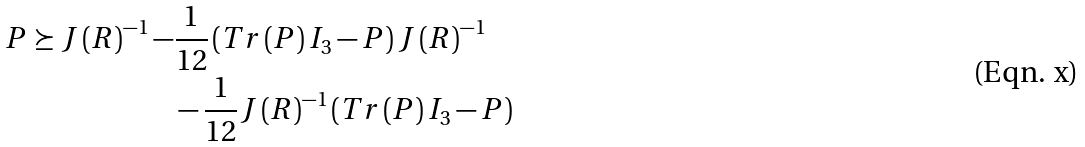<formula> <loc_0><loc_0><loc_500><loc_500>P \succeq J \left ( R \right ) ^ { - 1 } - & \frac { 1 } { 1 2 } \left ( T r \left ( P \right ) I _ { 3 } - P \right ) J \left ( R \right ) ^ { - 1 } \\ & - \frac { 1 } { 1 2 } J \left ( R \right ) ^ { - 1 } \left ( T r \left ( P \right ) I _ { 3 } - P \right )</formula> 